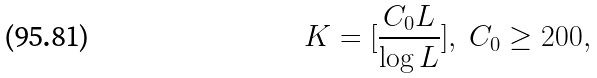<formula> <loc_0><loc_0><loc_500><loc_500>K = [ \frac { C _ { 0 } L } { \log L } ] , \ C _ { 0 } \geq 2 0 0 ,</formula> 